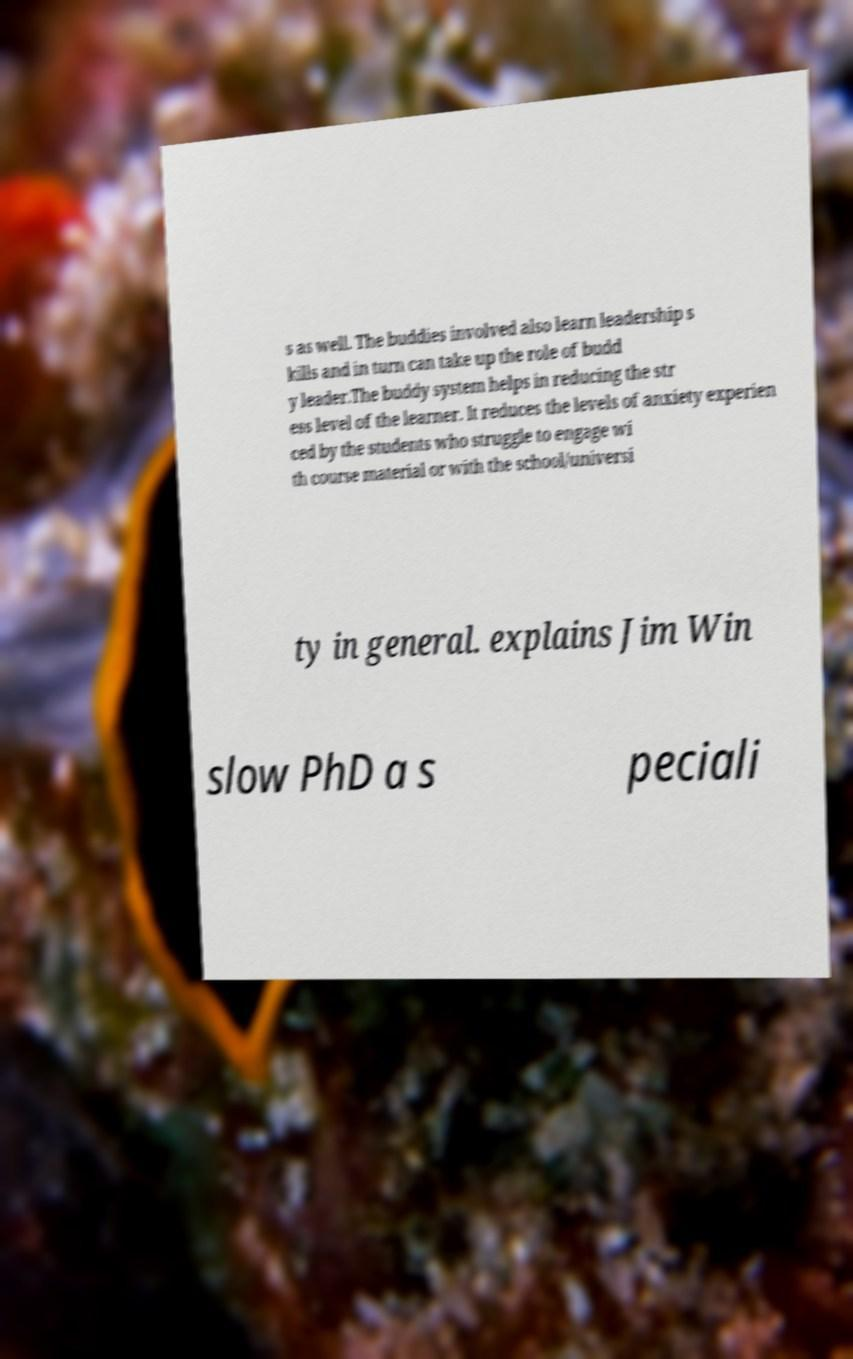Please identify and transcribe the text found in this image. s as well. The buddies involved also learn leadership s kills and in turn can take up the role of budd y leader.The buddy system helps in reducing the str ess level of the learner. It reduces the levels of anxiety experien ced by the students who struggle to engage wi th course material or with the school/universi ty in general. explains Jim Win slow PhD a s peciali 